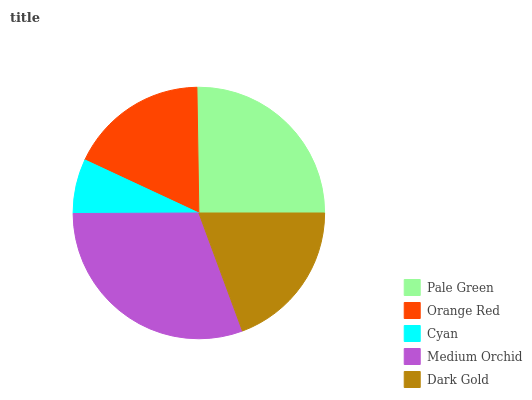Is Cyan the minimum?
Answer yes or no. Yes. Is Medium Orchid the maximum?
Answer yes or no. Yes. Is Orange Red the minimum?
Answer yes or no. No. Is Orange Red the maximum?
Answer yes or no. No. Is Pale Green greater than Orange Red?
Answer yes or no. Yes. Is Orange Red less than Pale Green?
Answer yes or no. Yes. Is Orange Red greater than Pale Green?
Answer yes or no. No. Is Pale Green less than Orange Red?
Answer yes or no. No. Is Dark Gold the high median?
Answer yes or no. Yes. Is Dark Gold the low median?
Answer yes or no. Yes. Is Cyan the high median?
Answer yes or no. No. Is Cyan the low median?
Answer yes or no. No. 